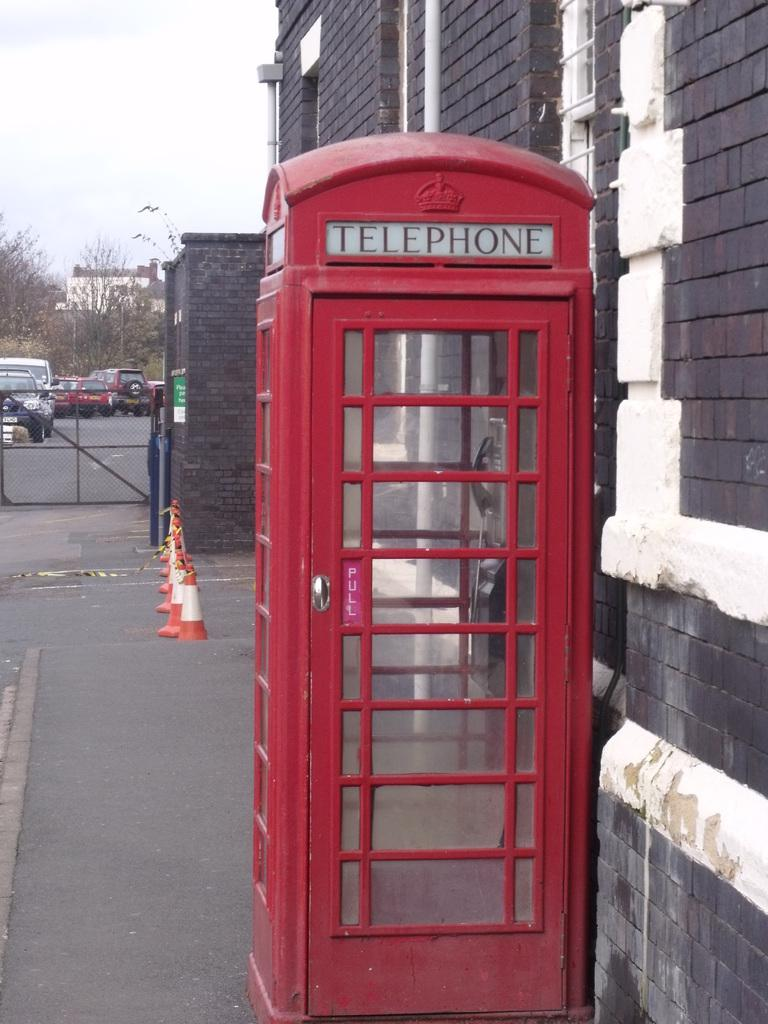Provide a one-sentence caption for the provided image. A red telephone booth like the one in Dr Strange on the sidewalk. 